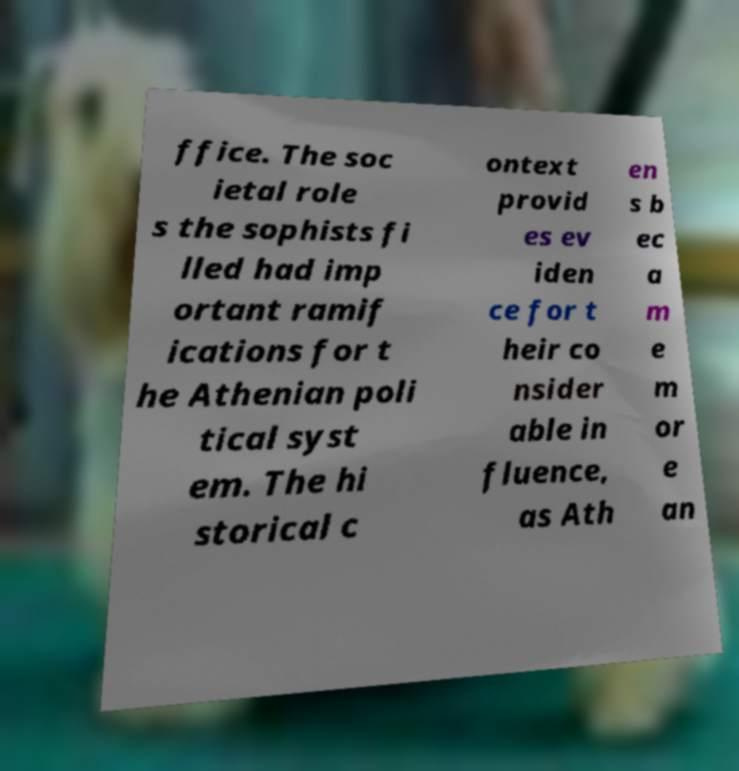Can you read and provide the text displayed in the image?This photo seems to have some interesting text. Can you extract and type it out for me? ffice. The soc ietal role s the sophists fi lled had imp ortant ramif ications for t he Athenian poli tical syst em. The hi storical c ontext provid es ev iden ce for t heir co nsider able in fluence, as Ath en s b ec a m e m or e an 